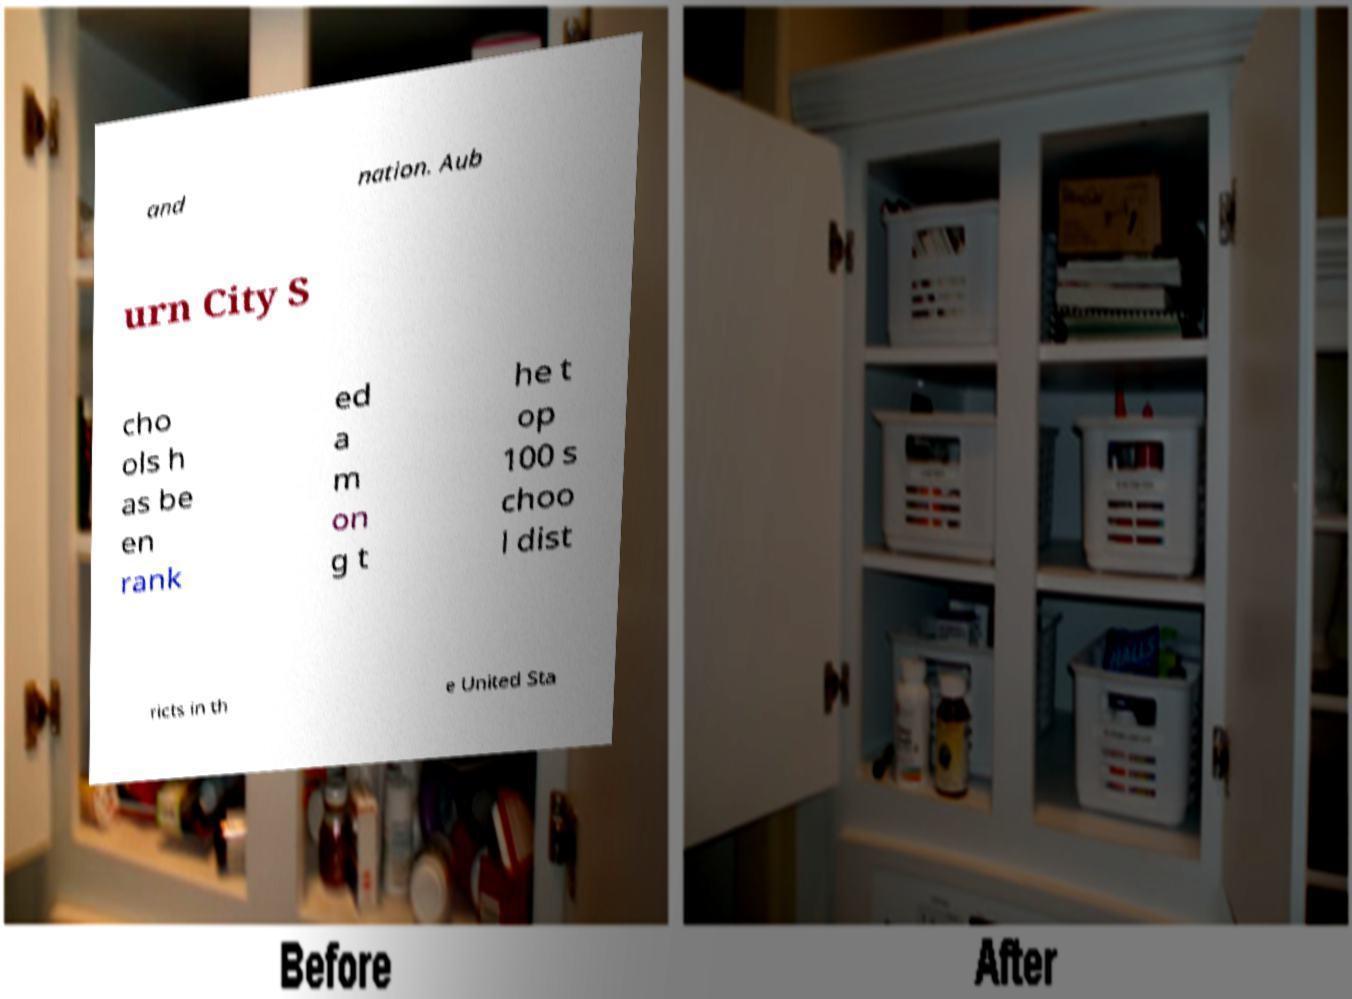What messages or text are displayed in this image? I need them in a readable, typed format. and nation. Aub urn City S cho ols h as be en rank ed a m on g t he t op 100 s choo l dist ricts in th e United Sta 